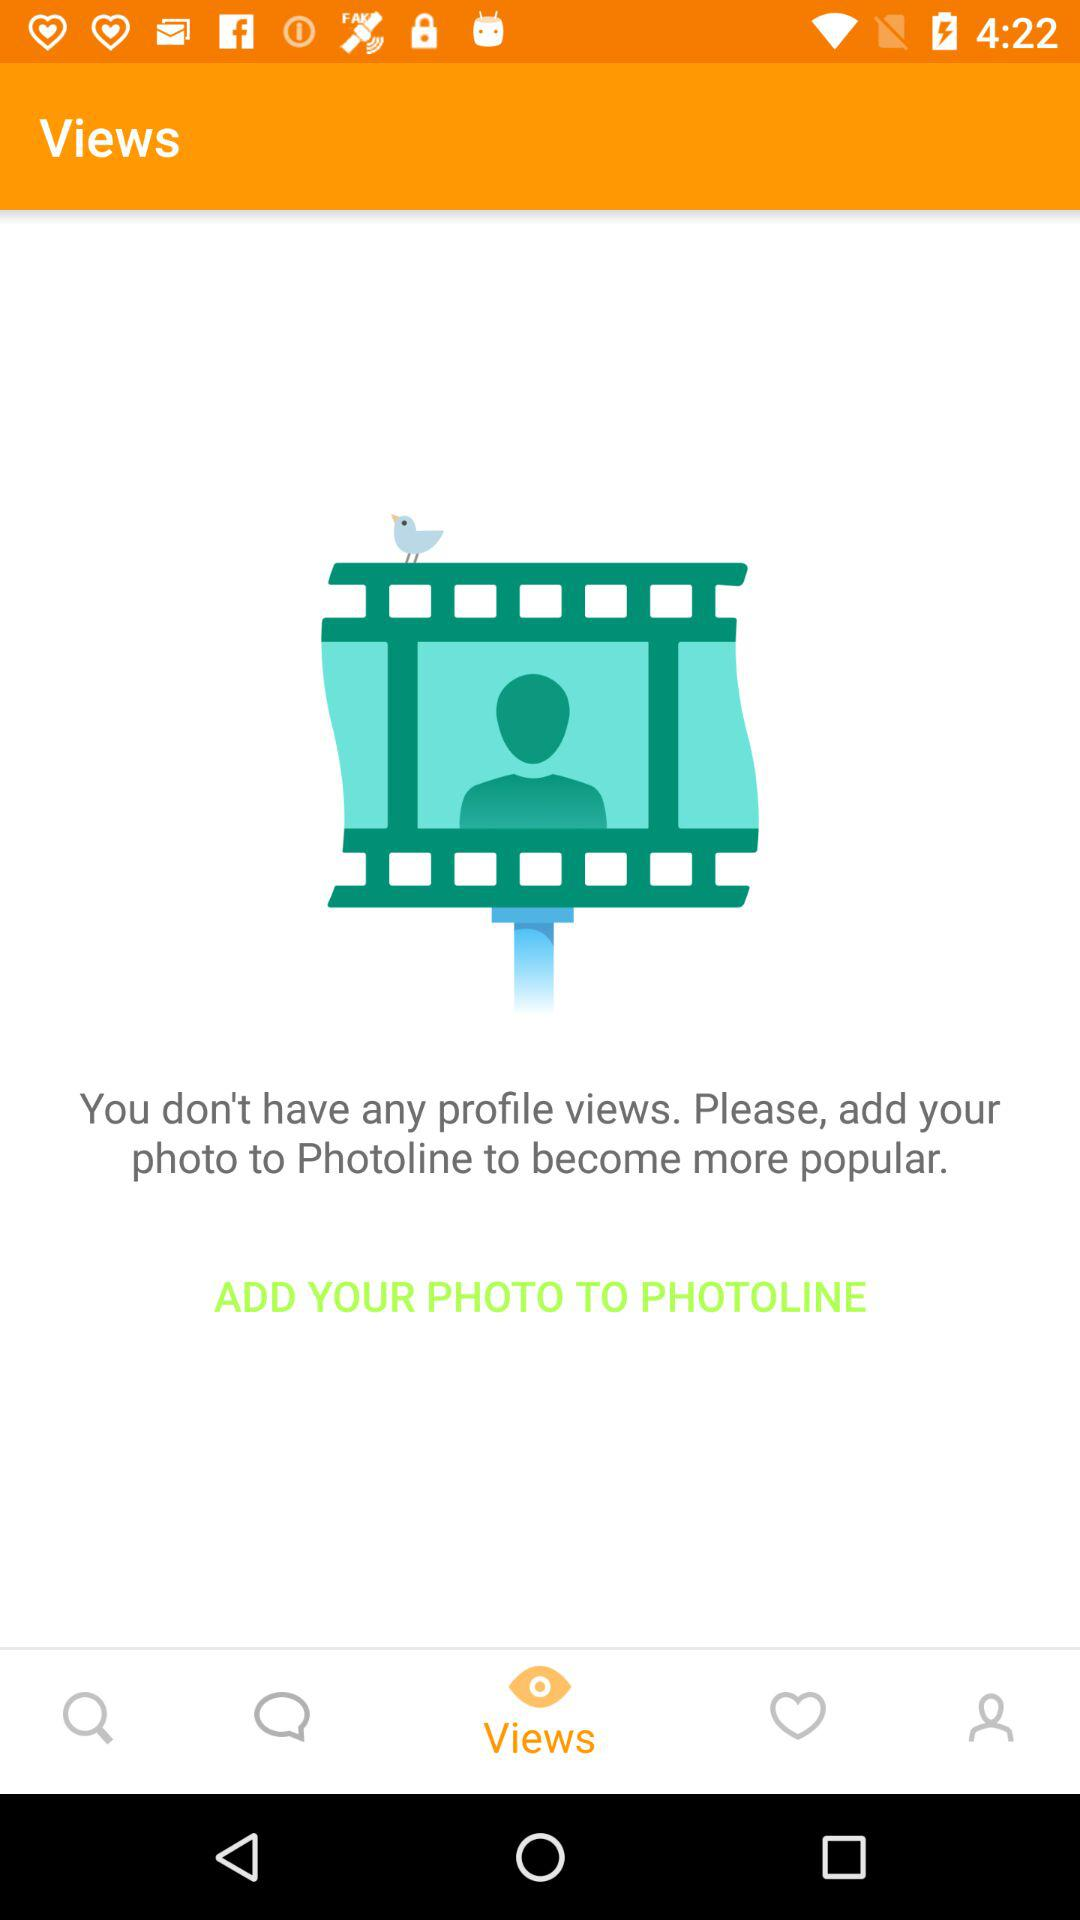Which tab is selected? The selected tab is "Views". 